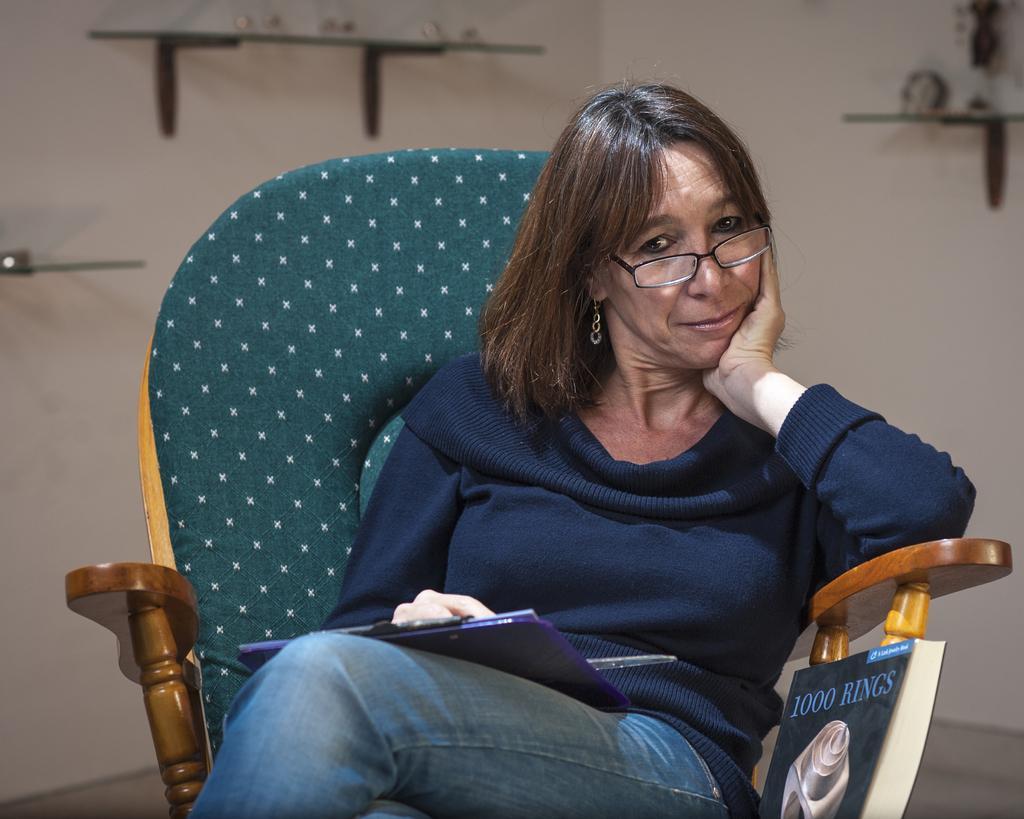How would you summarize this image in a sentence or two? In front of the picture, we see a woman in blue T-shirt is sitting on the chair. She is wearing the spectacles. She is smiling and she is posing for the photo. He is holding a blue book in her hand. Beside her, we see a book is placed on the chair. In the background, we see a white wall and glass shelves in which some objects are placed. This picture is clicked inside the room. 